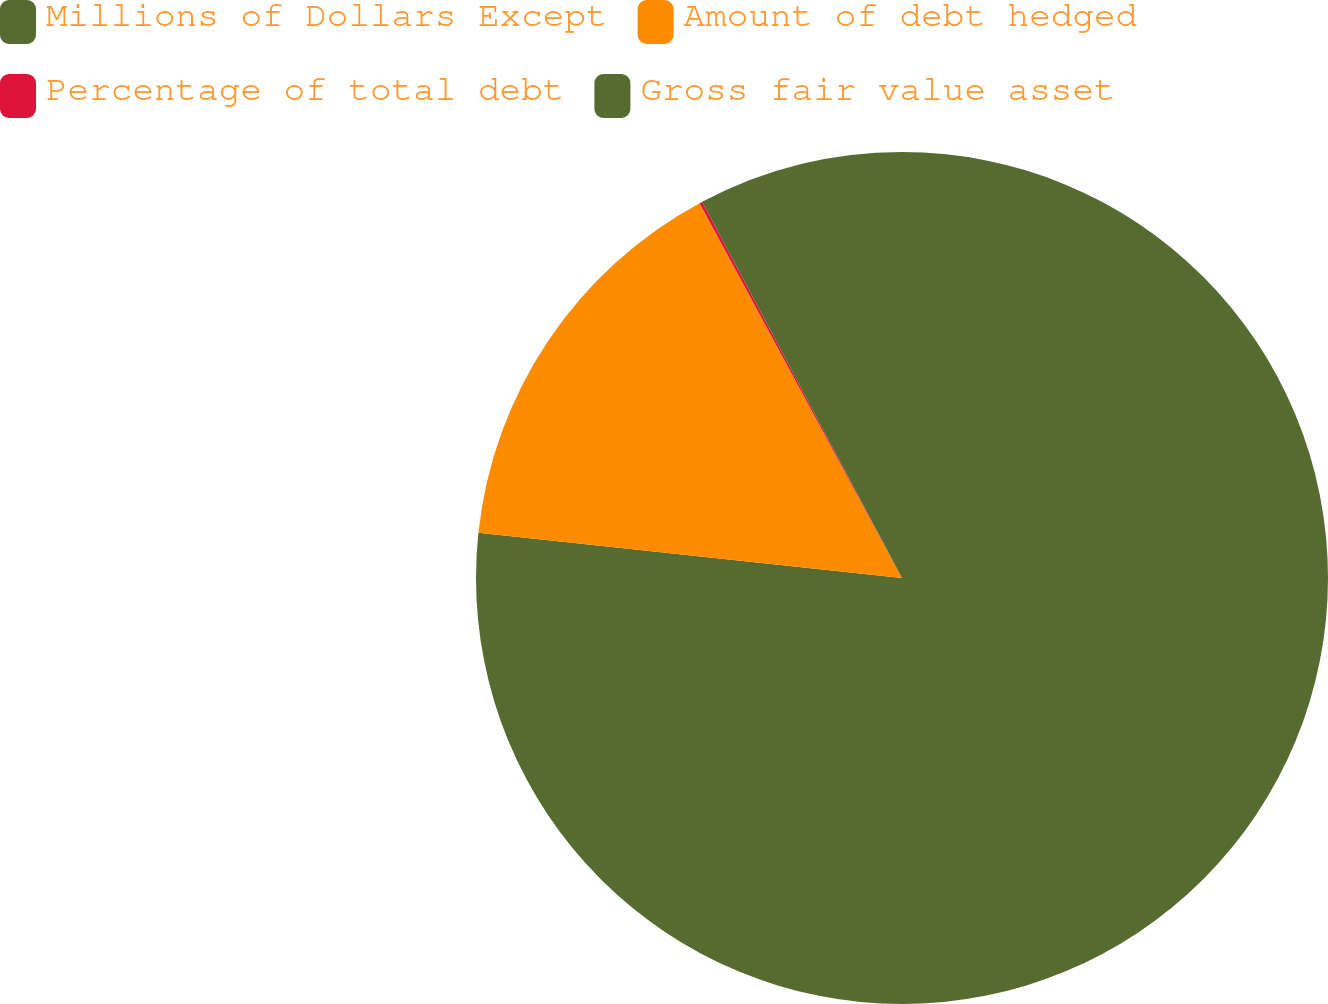Convert chart to OTSL. <chart><loc_0><loc_0><loc_500><loc_500><pie_chart><fcel>Millions of Dollars Except<fcel>Amount of debt hedged<fcel>Percentage of total debt<fcel>Gross fair value asset<nl><fcel>76.69%<fcel>15.43%<fcel>0.11%<fcel>7.77%<nl></chart> 